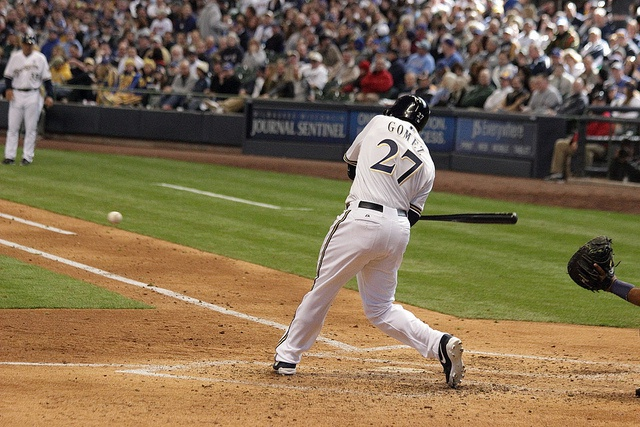Describe the objects in this image and their specific colors. I can see people in black, gray, darkgray, and maroon tones, people in black, lightgray, darkgray, and gray tones, people in black, darkgray, lightgray, and gray tones, baseball glove in black, darkgreen, and gray tones, and baseball bat in black and olive tones in this image. 